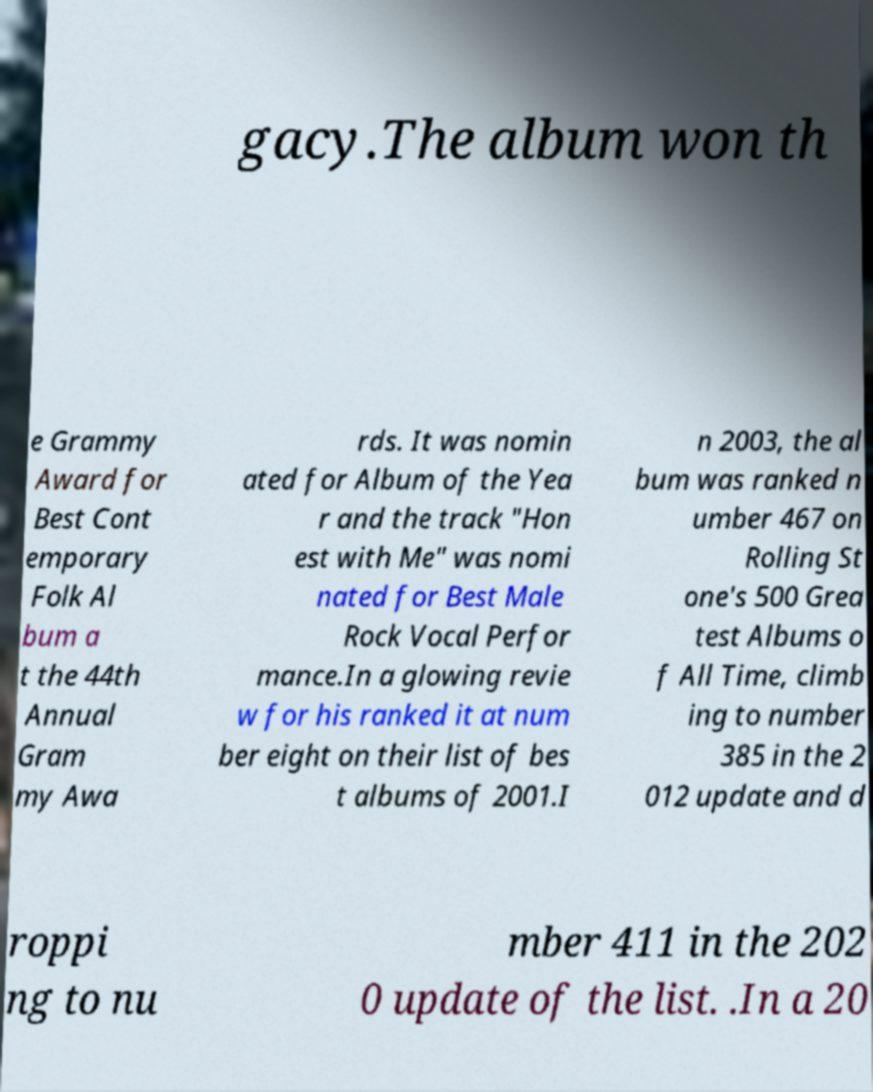I need the written content from this picture converted into text. Can you do that? gacy.The album won th e Grammy Award for Best Cont emporary Folk Al bum a t the 44th Annual Gram my Awa rds. It was nomin ated for Album of the Yea r and the track "Hon est with Me" was nomi nated for Best Male Rock Vocal Perfor mance.In a glowing revie w for his ranked it at num ber eight on their list of bes t albums of 2001.I n 2003, the al bum was ranked n umber 467 on Rolling St one's 500 Grea test Albums o f All Time, climb ing to number 385 in the 2 012 update and d roppi ng to nu mber 411 in the 202 0 update of the list. .In a 20 